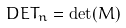<formula> <loc_0><loc_0><loc_500><loc_500>\ D E T _ { n } = \det ( M )</formula> 